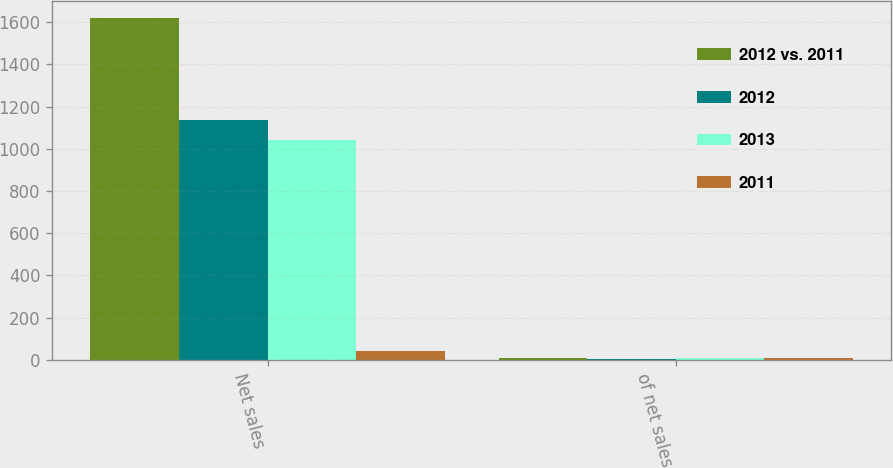Convert chart to OTSL. <chart><loc_0><loc_0><loc_500><loc_500><stacked_bar_chart><ecel><fcel>Net sales<fcel>of net sales<nl><fcel>2012 vs. 2011<fcel>1618.5<fcel>9.2<nl><fcel>2012<fcel>1136.7<fcel>3.1<nl><fcel>2013<fcel>1042.7<fcel>9.4<nl><fcel>2011<fcel>42.4<fcel>6.1<nl></chart> 